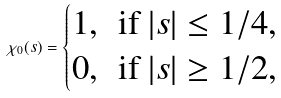Convert formula to latex. <formula><loc_0><loc_0><loc_500><loc_500>\chi _ { 0 } ( s ) = \begin{cases} 1 , \, \text { if } | s | \leq 1 / 4 , \\ 0 , \, \text { if } | s | \geq 1 / 2 , \end{cases}</formula> 